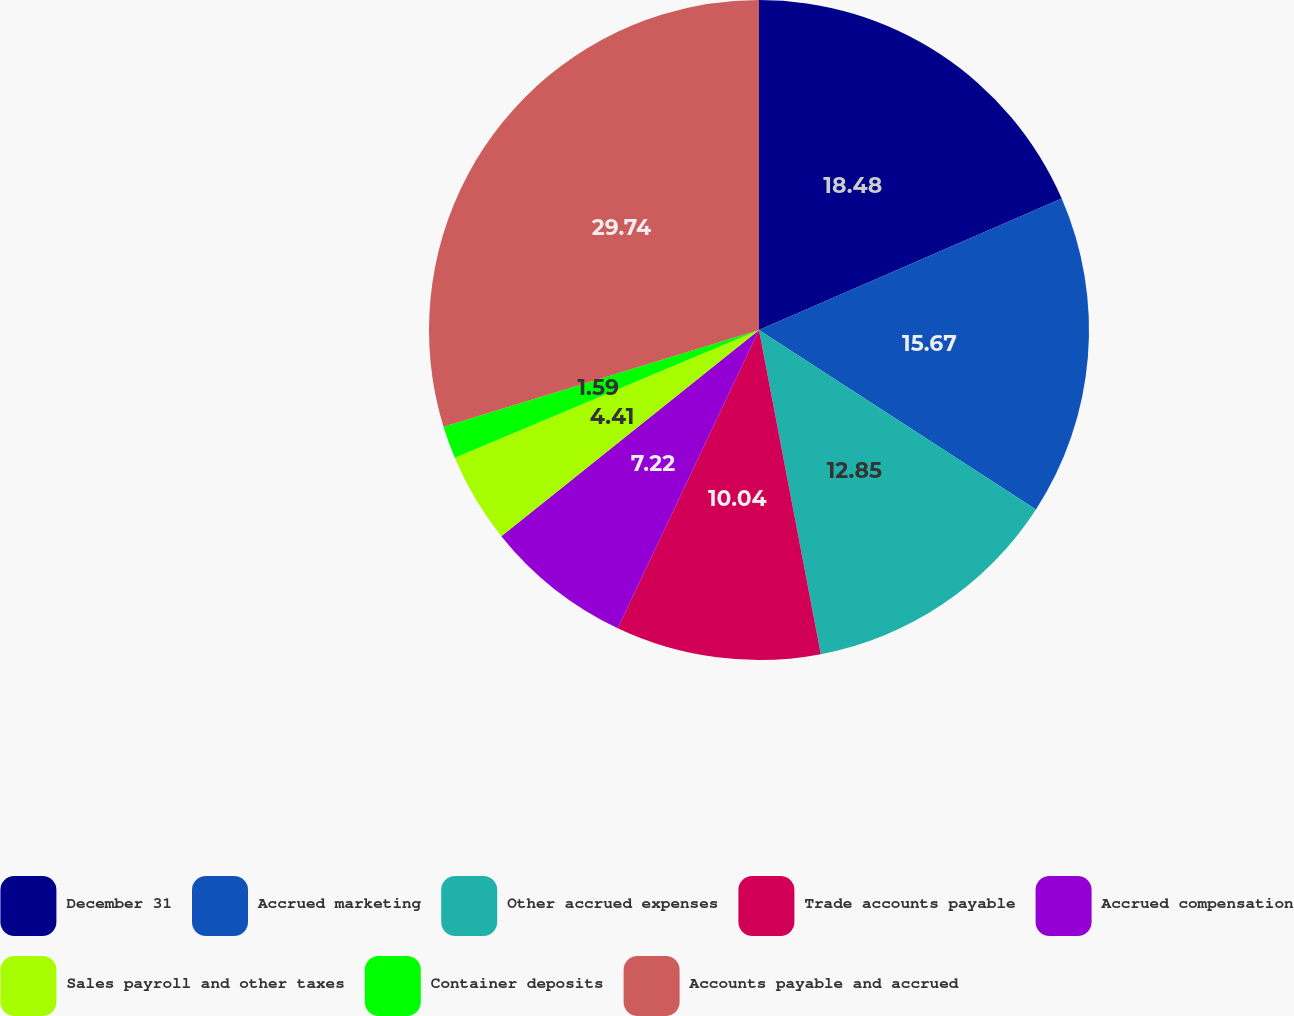Convert chart to OTSL. <chart><loc_0><loc_0><loc_500><loc_500><pie_chart><fcel>December 31<fcel>Accrued marketing<fcel>Other accrued expenses<fcel>Trade accounts payable<fcel>Accrued compensation<fcel>Sales payroll and other taxes<fcel>Container deposits<fcel>Accounts payable and accrued<nl><fcel>18.48%<fcel>15.67%<fcel>12.85%<fcel>10.04%<fcel>7.22%<fcel>4.41%<fcel>1.59%<fcel>29.74%<nl></chart> 